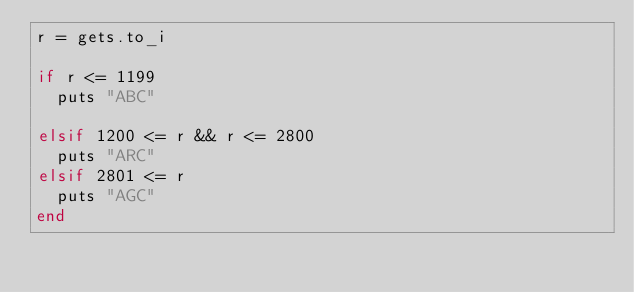Convert code to text. <code><loc_0><loc_0><loc_500><loc_500><_Ruby_>r = gets.to_i

if r <= 1199
  puts "ABC"

elsif 1200 <= r && r <= 2800
  puts "ARC"
elsif 2801 <= r
  puts "AGC"
end</code> 